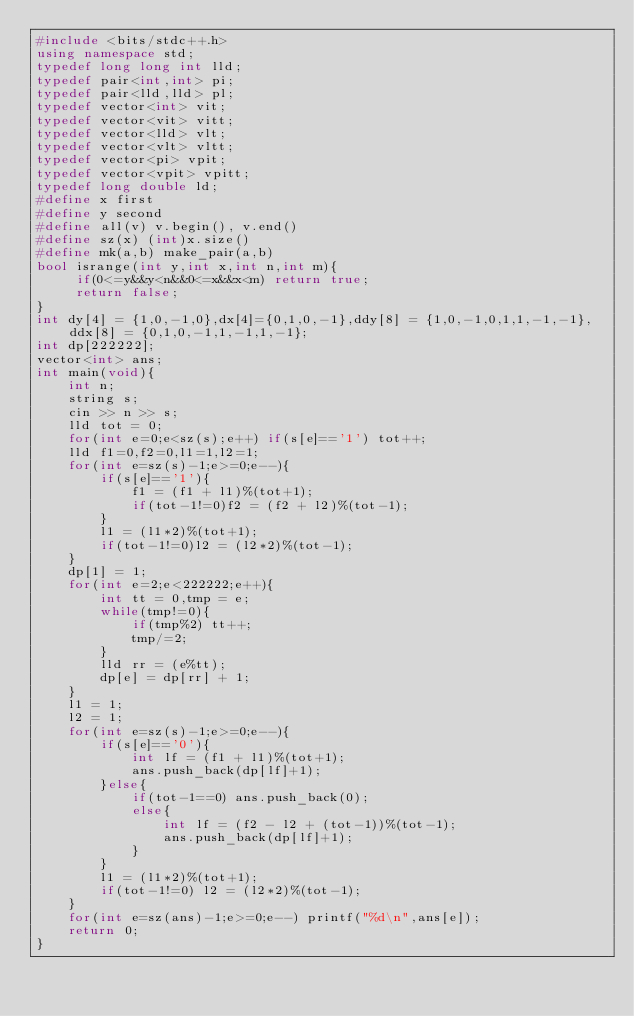Convert code to text. <code><loc_0><loc_0><loc_500><loc_500><_C++_>#include <bits/stdc++.h>
using namespace std;
typedef long long int lld;
typedef pair<int,int> pi;
typedef pair<lld,lld> pl;
typedef vector<int> vit;
typedef vector<vit> vitt;
typedef vector<lld> vlt;
typedef vector<vlt> vltt;
typedef vector<pi> vpit;
typedef vector<vpit> vpitt;
typedef long double ld;
#define x first
#define y second
#define all(v) v.begin(), v.end()
#define sz(x) (int)x.size()
#define mk(a,b) make_pair(a,b)
bool isrange(int y,int x,int n,int m){
	 if(0<=y&&y<n&&0<=x&&x<m) return true;
	 return false;
}
int dy[4] = {1,0,-1,0},dx[4]={0,1,0,-1},ddy[8] = {1,0,-1,0,1,1,-1,-1},ddx[8] = {0,1,0,-1,1,-1,1,-1};
int dp[222222];
vector<int> ans;
int main(void){
	int n;
	string s;
	cin >> n >> s;
	lld tot = 0;
	for(int e=0;e<sz(s);e++) if(s[e]=='1') tot++;
	lld f1=0,f2=0,l1=1,l2=1;
	for(int e=sz(s)-1;e>=0;e--){
		if(s[e]=='1'){
			f1 = (f1 + l1)%(tot+1);
			if(tot-1!=0)f2 = (f2 + l2)%(tot-1);
		}
		l1 = (l1*2)%(tot+1);
		if(tot-1!=0)l2 = (l2*2)%(tot-1);
	}
	dp[1] = 1;
	for(int e=2;e<222222;e++){
		int tt = 0,tmp = e;
		while(tmp!=0){
			if(tmp%2) tt++;
			tmp/=2;
		}
		lld rr = (e%tt);
		dp[e] = dp[rr] + 1;
	}
	l1 = 1;
	l2 = 1;
	for(int e=sz(s)-1;e>=0;e--){
		if(s[e]=='0'){
			int lf = (f1 + l1)%(tot+1);
			ans.push_back(dp[lf]+1);
		}else{
			if(tot-1==0) ans.push_back(0);
			else{
				int lf = (f2 - l2 + (tot-1))%(tot-1);
				ans.push_back(dp[lf]+1);
			}
		}
		l1 = (l1*2)%(tot+1);
		if(tot-1!=0) l2 = (l2*2)%(tot-1);
	}
	for(int e=sz(ans)-1;e>=0;e--) printf("%d\n",ans[e]);
	return 0;
}
</code> 